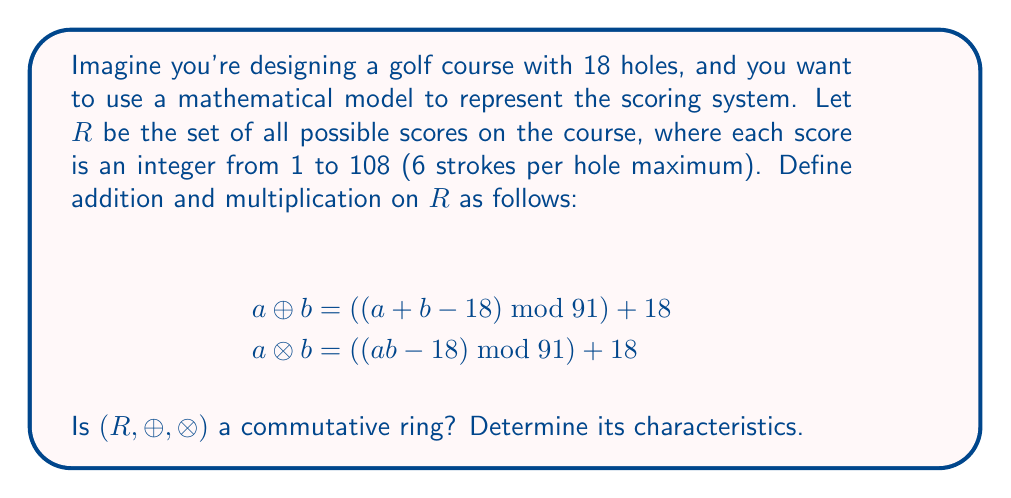What is the answer to this math problem? To determine if $(R, \oplus, \otimes)$ is a commutative ring and identify its characteristics, we need to check the ring axioms:

1. $(R, \oplus)$ is an abelian group:
   a) Closure: For any $a, b \in R$, $a \oplus b \in R$ (always between 18 and 108)
   b) Associativity: $(a \oplus b) \oplus c = a \oplus (b \oplus c)$ (modular arithmetic is associative)
   c) Identity: The identity element is 18, as $a \oplus 18 = a$ for all $a \in R$
   d) Inverse: For each $a \in R$, there exists $-a = (109 - a) \bmod 91 + 18$ such that $a \oplus (-a) = 18$
   e) Commutativity: $a \oplus b = b \oplus a$ (addition is commutative)

2. $(R, \otimes)$ is a monoid:
   a) Closure: For any $a, b \in R$, $a \otimes b \in R$ (always between 18 and 108)
   b) Associativity: $(a \otimes b) \otimes c = a \otimes (b \otimes c)$ (modular arithmetic is associative)
   c) Identity: The identity element is 19, as $a \otimes 19 = a$ for all $a \in R$

3. Distributivity:
   $a \otimes (b \oplus c) = (a \otimes b) \oplus (a \otimes c)$ (holds due to modular arithmetic properties)

4. Commutativity of multiplication:
   $a \otimes b = b \otimes a$ (multiplication is commutative)

Since all ring axioms are satisfied and multiplication is commutative, $(R, \oplus, \otimes)$ is indeed a commutative ring.

Characteristics:
1. The ring has 91 elements (scores from 18 to 108).
2. The additive identity is 18.
3. The multiplicative identity is 19.
4. The ring has zero divisors (e.g., $20 \otimes 55 = 18$).
5. The ring is not an integral domain due to the presence of zero divisors.
6. The ring has characteristic 0, as no positive integer $n$ exists such that $n \otimes a = 18$ for all $a \in R$.
Answer: Yes, $(R, \oplus, \otimes)$ is a commutative ring with 91 elements, additive identity 18, multiplicative identity 19, zero divisors, and characteristic 0. 